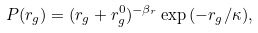Convert formula to latex. <formula><loc_0><loc_0><loc_500><loc_500>P ( r _ { g } ) = ( r _ { g } + r _ { g } ^ { 0 } ) ^ { - \beta _ { r } } \exp { ( - r _ { g } / \kappa ) } ,</formula> 